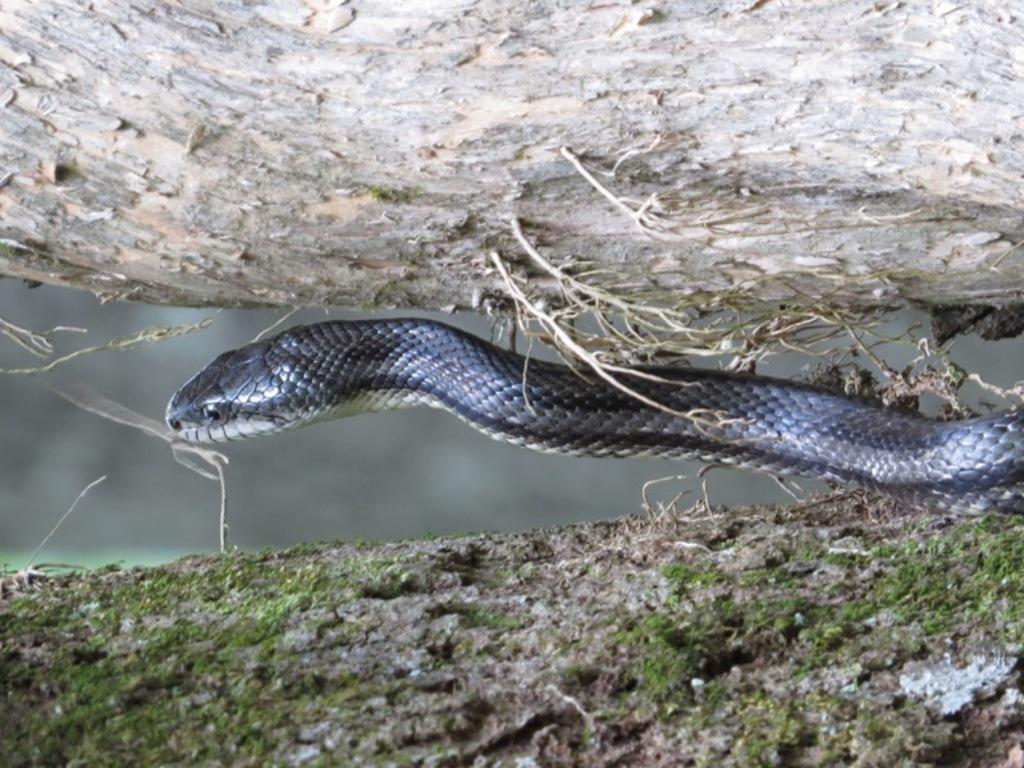How would you summarize this image in a sentence or two? In this image there is a Snake in between the tree trunks , and there is blur background. 